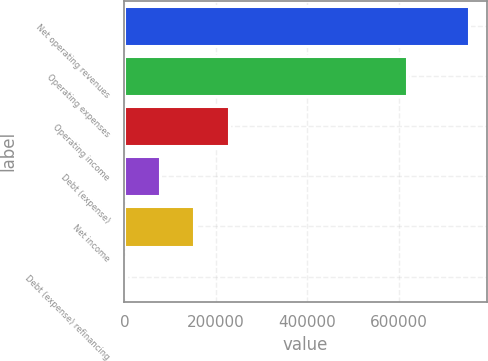Convert chart. <chart><loc_0><loc_0><loc_500><loc_500><bar_chart><fcel>Net operating revenues<fcel>Operating expenses<fcel>Operating income<fcel>Debt (expense)<fcel>Net income<fcel>Debt (expense) refinancing<nl><fcel>754163<fcel>617159<fcel>227995<fcel>77661.8<fcel>152829<fcel>2495<nl></chart> 